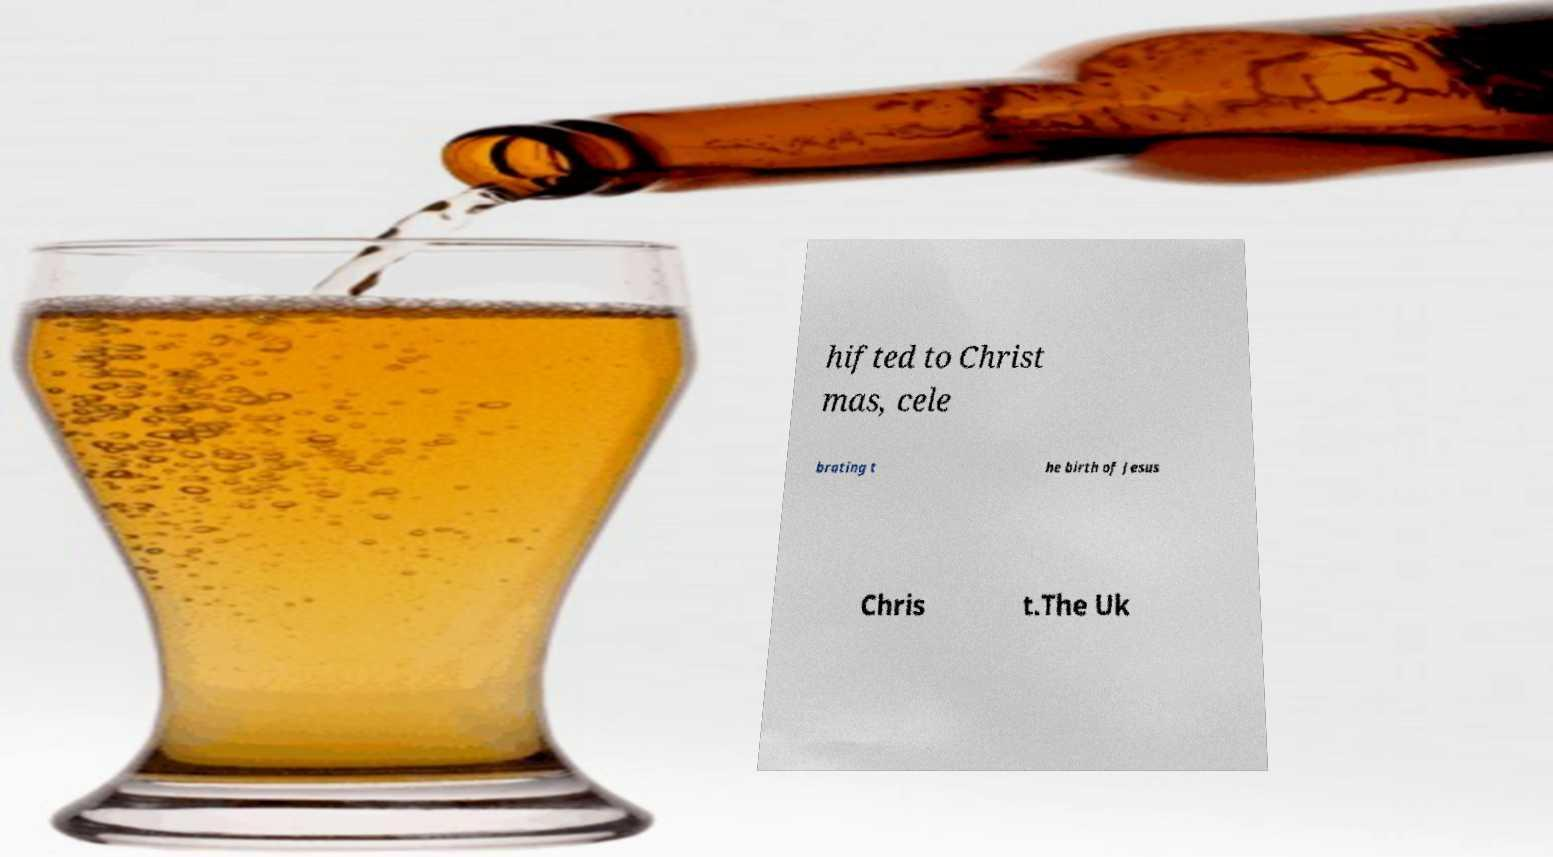Please identify and transcribe the text found in this image. hifted to Christ mas, cele brating t he birth of Jesus Chris t.The Uk 